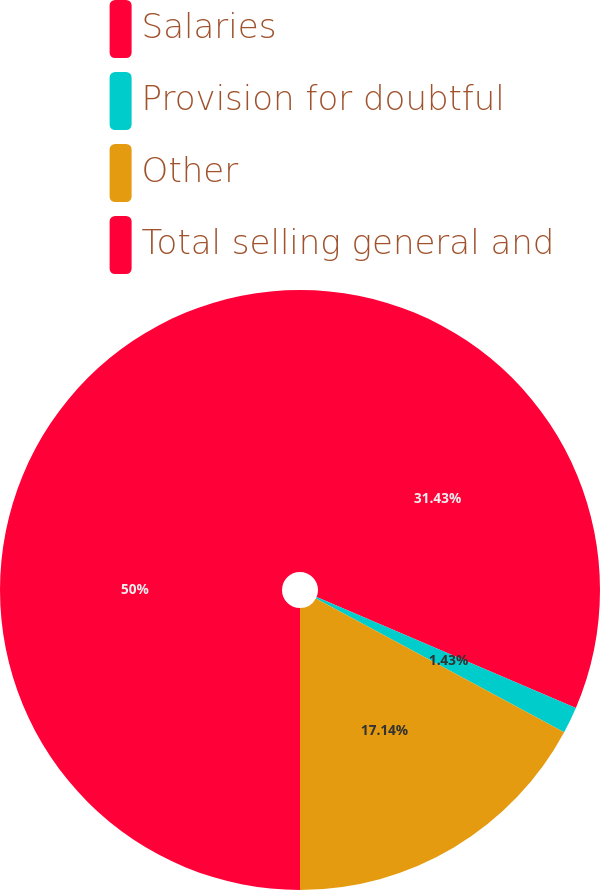<chart> <loc_0><loc_0><loc_500><loc_500><pie_chart><fcel>Salaries<fcel>Provision for doubtful<fcel>Other<fcel>Total selling general and<nl><fcel>31.43%<fcel>1.43%<fcel>17.14%<fcel>50.0%<nl></chart> 